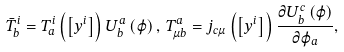Convert formula to latex. <formula><loc_0><loc_0><loc_500><loc_500>\bar { T } _ { b } ^ { i } = T _ { a } ^ { i } \left ( \left [ y ^ { i } \right ] \right ) U _ { b } ^ { a } \left ( \varphi \right ) , \, T _ { \mu b } ^ { a } = j _ { c \mu } \left ( \left [ y ^ { i } \right ] \right ) \frac { \partial U _ { b } ^ { c } \left ( \varphi \right ) } { \partial \varphi _ { a } } ,</formula> 